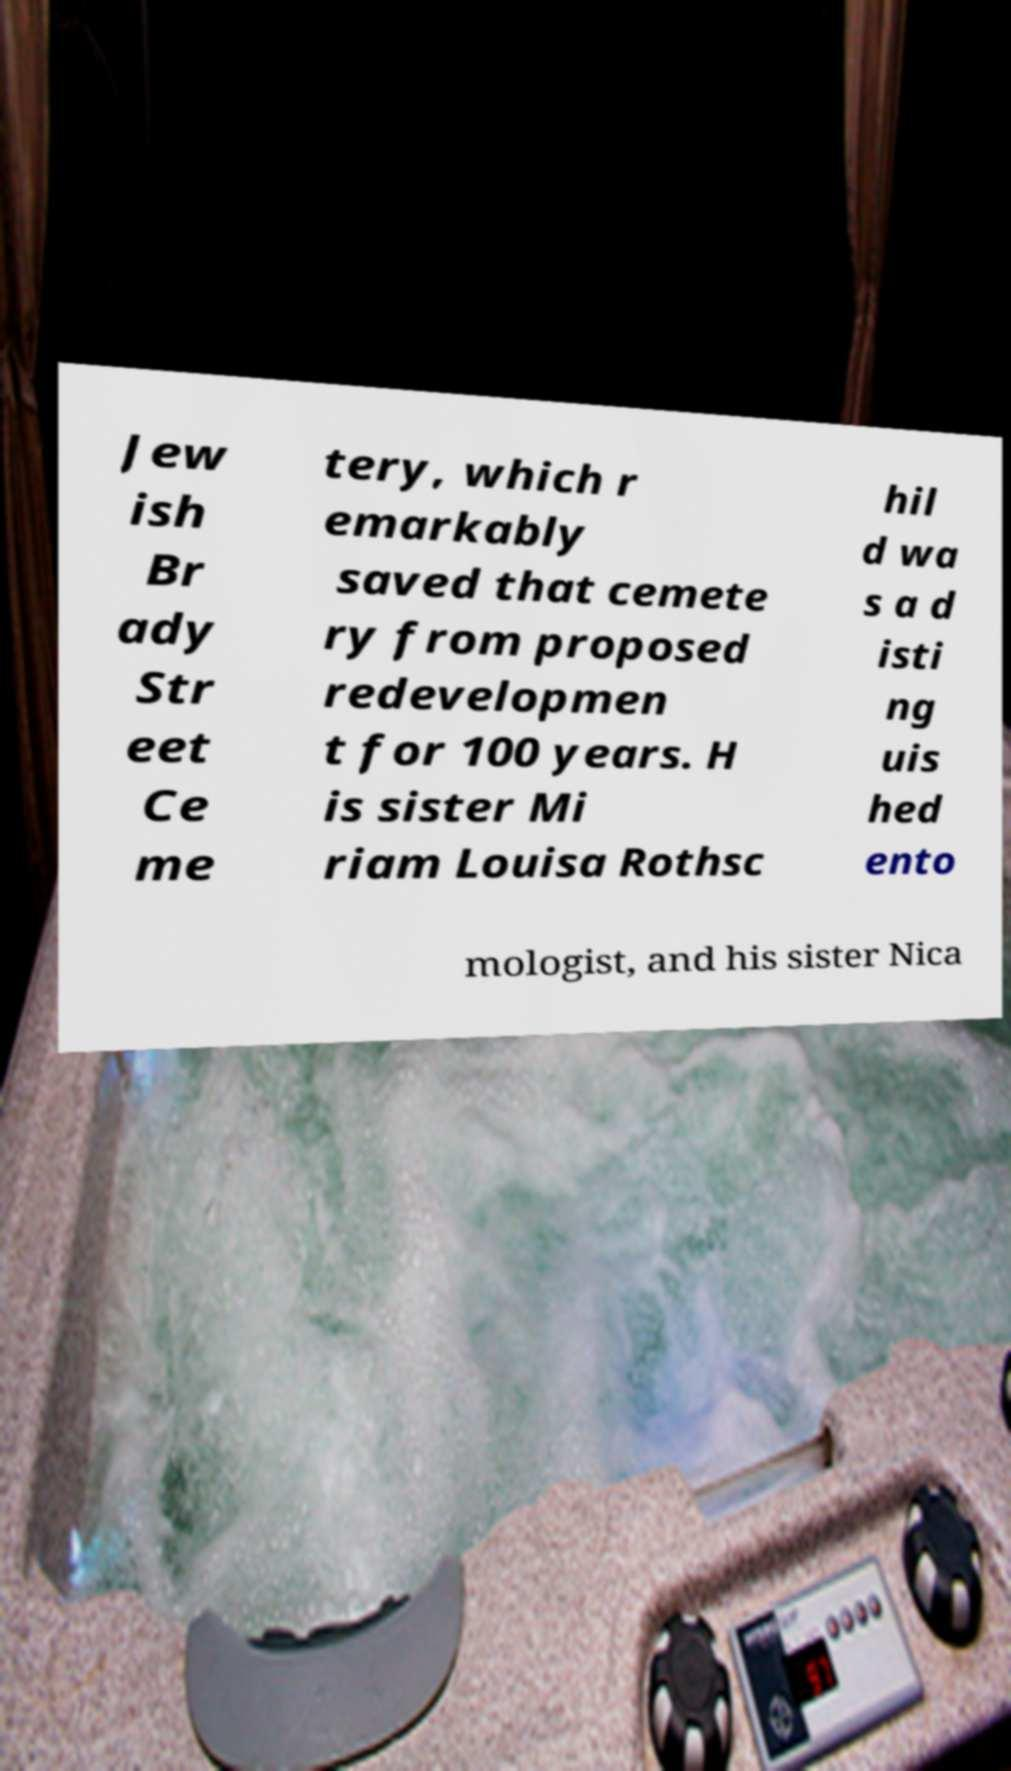Please identify and transcribe the text found in this image. Jew ish Br ady Str eet Ce me tery, which r emarkably saved that cemete ry from proposed redevelopmen t for 100 years. H is sister Mi riam Louisa Rothsc hil d wa s a d isti ng uis hed ento mologist, and his sister Nica 